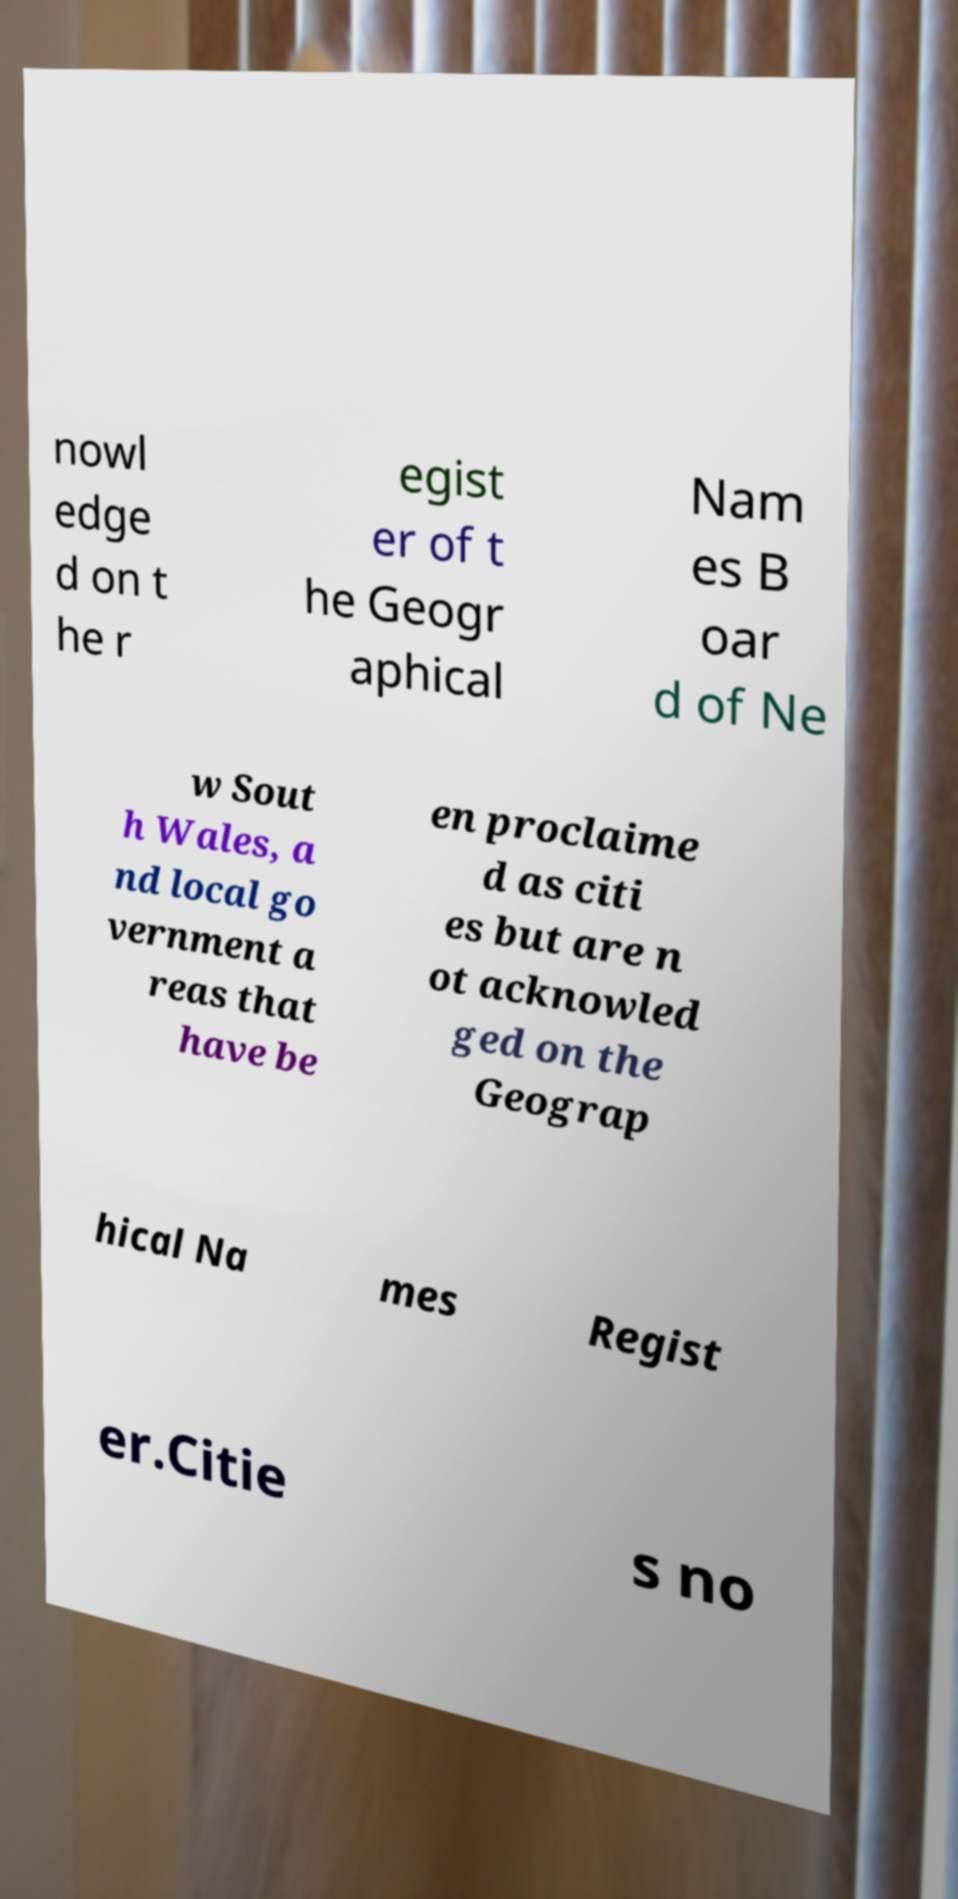There's text embedded in this image that I need extracted. Can you transcribe it verbatim? nowl edge d on t he r egist er of t he Geogr aphical Nam es B oar d of Ne w Sout h Wales, a nd local go vernment a reas that have be en proclaime d as citi es but are n ot acknowled ged on the Geograp hical Na mes Regist er.Citie s no 